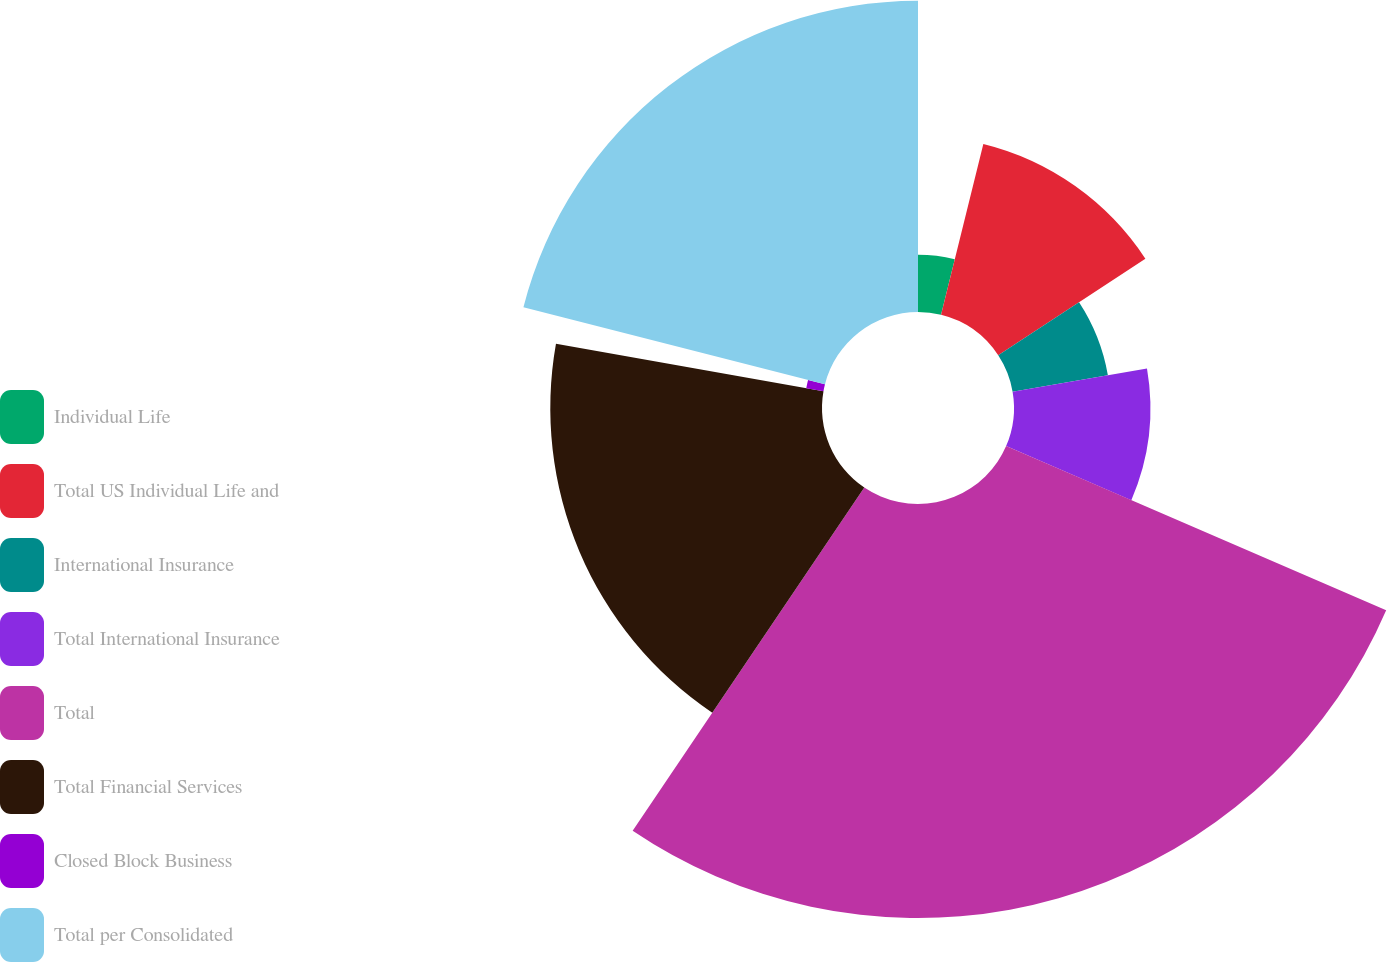Convert chart to OTSL. <chart><loc_0><loc_0><loc_500><loc_500><pie_chart><fcel>Individual Life<fcel>Total US Individual Life and<fcel>International Insurance<fcel>Total International Insurance<fcel>Total<fcel>Total Financial Services<fcel>Closed Block Business<fcel>Total per Consolidated<nl><fcel>3.86%<fcel>11.89%<fcel>6.53%<fcel>9.21%<fcel>27.96%<fcel>18.35%<fcel>1.18%<fcel>21.02%<nl></chart> 